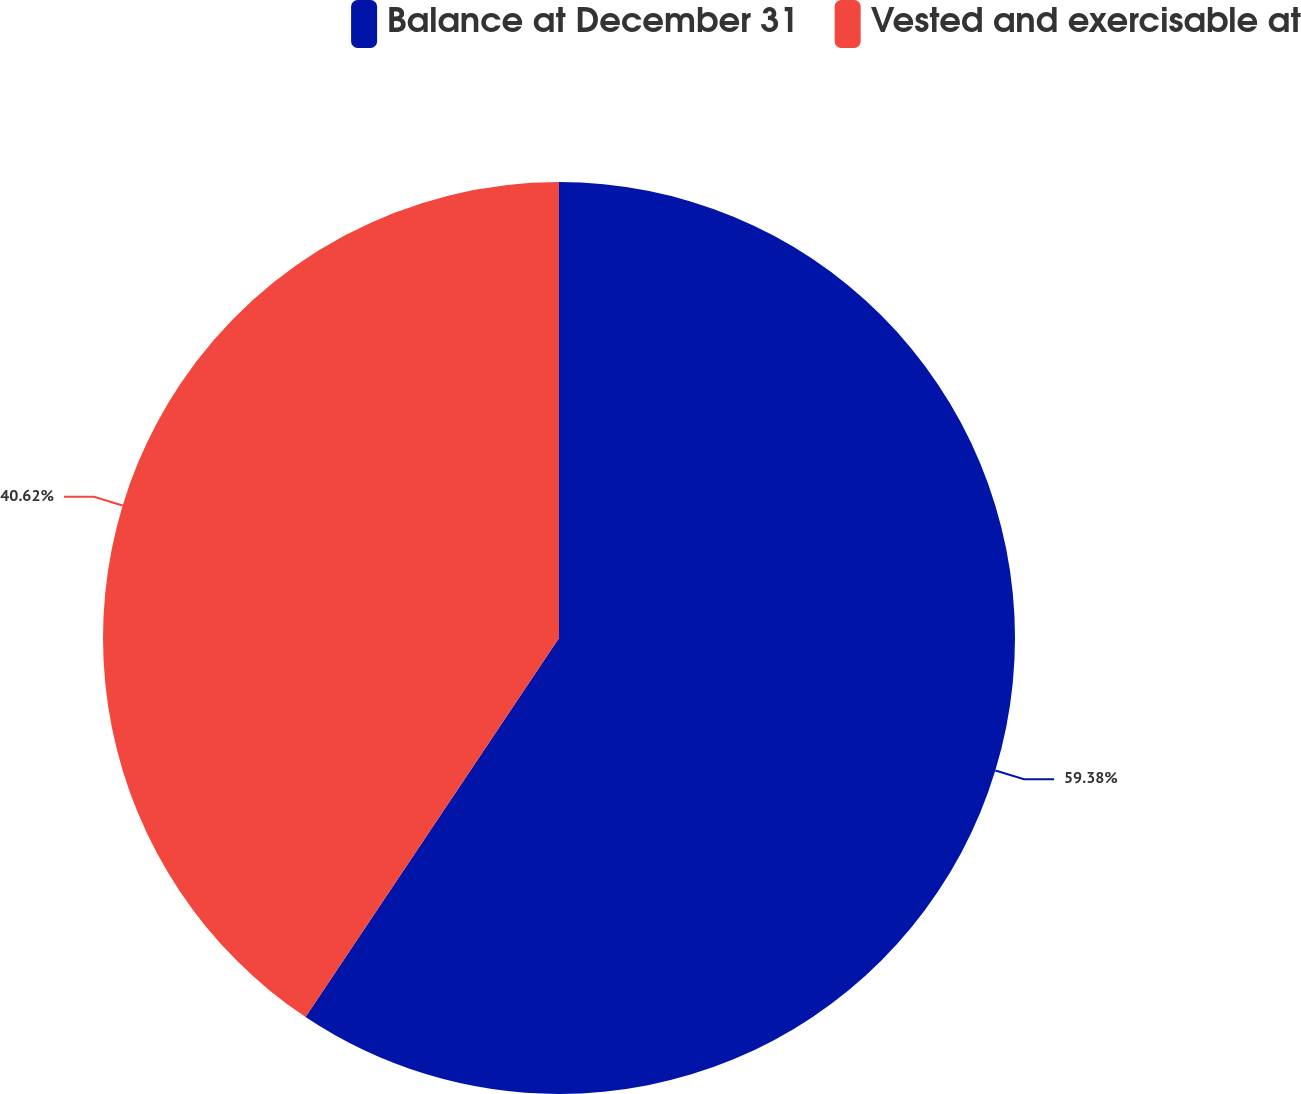Convert chart. <chart><loc_0><loc_0><loc_500><loc_500><pie_chart><fcel>Balance at December 31<fcel>Vested and exercisable at<nl><fcel>59.38%<fcel>40.62%<nl></chart> 